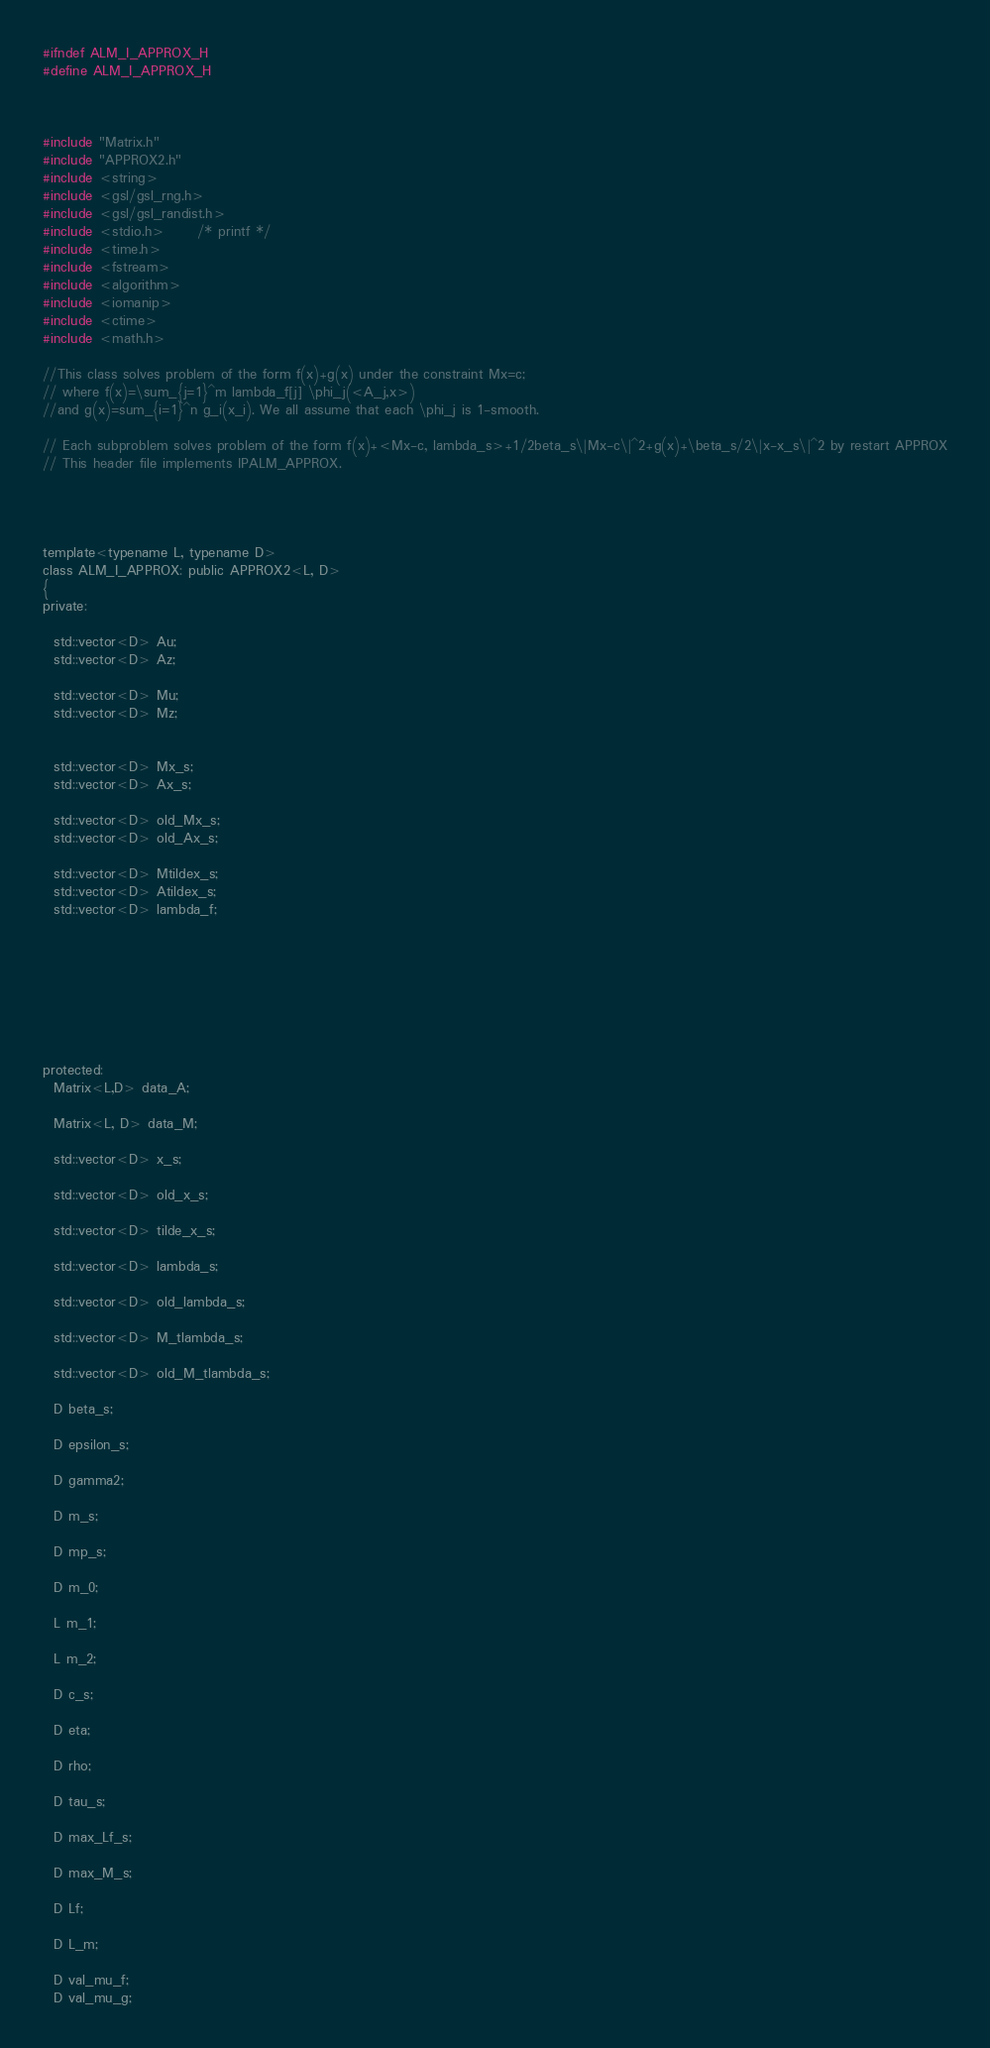Convert code to text. <code><loc_0><loc_0><loc_500><loc_500><_C_>#ifndef ALM_I_APPROX_H
#define ALM_I_APPROX_H



#include "Matrix.h"
#include "APPROX2.h"
#include <string>
#include <gsl/gsl_rng.h>
#include <gsl/gsl_randist.h>
#include <stdio.h>      /* printf */
#include <time.h>
#include <fstream>
#include <algorithm>
#include <iomanip>
#include <ctime>
#include <math.h>

//This class solves problem of the form f(x)+g(x) under the constraint Mx=c;
// where f(x)=\sum_{j=1}^m lambda_f[j] \phi_j(<A_j,x>)
//and g(x)=sum_{i=1}^n g_i(x_i). We all assume that each \phi_j is 1-smooth.

// Each subproblem solves problem of the form f(x)+<Mx-c, lambda_s>+1/2beta_s\|Mx-c\|^2+g(x)+\beta_s/2\|x-x_s\|^2 by restart APPROX
// This header file implements IPALM_APPROX.




template<typename L, typename D>
class ALM_I_APPROX: public APPROX2<L, D>
{
private:

  std::vector<D> Au;
  std::vector<D> Az;

  std::vector<D> Mu;
  std::vector<D> Mz;


  std::vector<D> Mx_s;
  std::vector<D> Ax_s;
  
  std::vector<D> old_Mx_s;
  std::vector<D> old_Ax_s;
  
  std::vector<D> Mtildex_s;
  std::vector<D> Atildex_s;
  std::vector<D> lambda_f;








protected:
  Matrix<L,D> data_A;

  Matrix<L, D> data_M;

  std::vector<D> x_s;
  
  std::vector<D> old_x_s;
  
  std::vector<D> tilde_x_s;

  std::vector<D> lambda_s;
  
  std::vector<D> old_lambda_s;

  std::vector<D> M_tlambda_s;
  
  std::vector<D> old_M_tlambda_s;

  D beta_s;

  D epsilon_s;
  
  D gamma2;

  D m_s;

  D mp_s;

  D m_0;

  L m_1;

  L m_2;

  D c_s;

  D eta;

  D rho;
  
  D tau_s;

  D max_Lf_s;

  D max_M_s;

  D Lf;

  D L_m;

  D val_mu_f;
  D val_mu_g;
</code> 